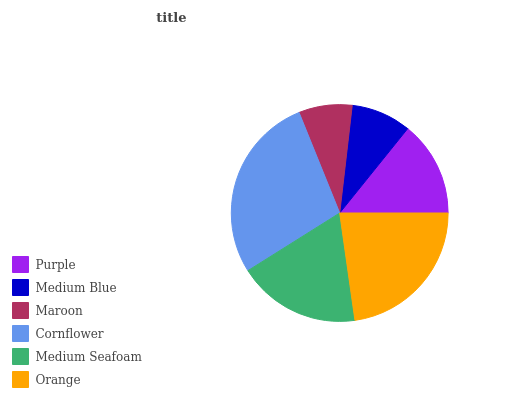Is Maroon the minimum?
Answer yes or no. Yes. Is Cornflower the maximum?
Answer yes or no. Yes. Is Medium Blue the minimum?
Answer yes or no. No. Is Medium Blue the maximum?
Answer yes or no. No. Is Purple greater than Medium Blue?
Answer yes or no. Yes. Is Medium Blue less than Purple?
Answer yes or no. Yes. Is Medium Blue greater than Purple?
Answer yes or no. No. Is Purple less than Medium Blue?
Answer yes or no. No. Is Medium Seafoam the high median?
Answer yes or no. Yes. Is Purple the low median?
Answer yes or no. Yes. Is Maroon the high median?
Answer yes or no. No. Is Cornflower the low median?
Answer yes or no. No. 